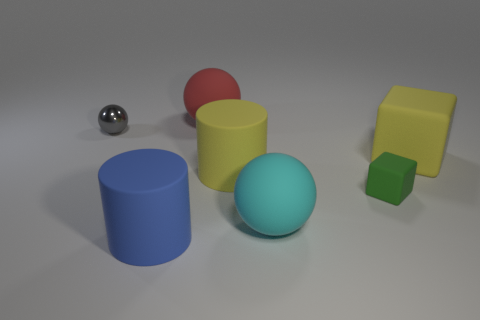What is the size of the cylinder that is the same color as the large rubber cube?
Ensure brevity in your answer.  Large. Are there any big red objects?
Keep it short and to the point. Yes. What is the shape of the tiny object on the right side of the large matte cylinder that is to the left of the big rubber cylinder right of the red matte sphere?
Make the answer very short. Cube. There is a green block; how many large yellow matte objects are on the left side of it?
Ensure brevity in your answer.  1. Is the large cylinder that is to the left of the big yellow cylinder made of the same material as the small green object?
Provide a succinct answer. Yes. What number of other objects are there of the same shape as the green matte thing?
Your response must be concise. 1. What number of gray metal things are right of the big yellow thing to the left of the large sphere in front of the small shiny sphere?
Keep it short and to the point. 0. What color is the large rubber ball in front of the small gray sphere?
Offer a terse response. Cyan. There is a tiny object that is on the left side of the yellow cylinder; does it have the same color as the big block?
Ensure brevity in your answer.  No. There is a red object that is the same shape as the big cyan object; what is its size?
Make the answer very short. Large. 